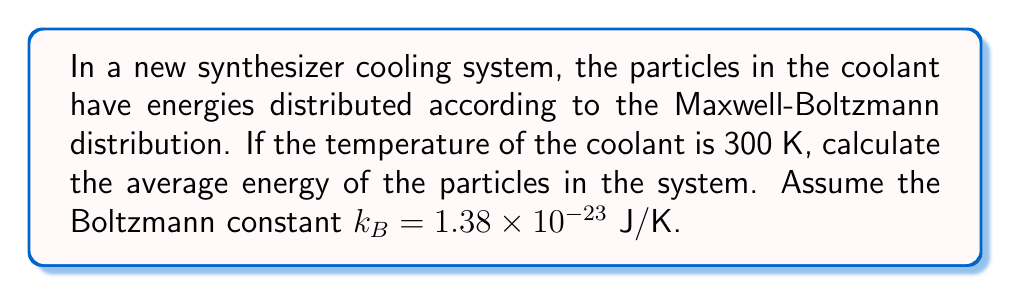Solve this math problem. To solve this problem, we'll follow these steps:

1) In statistical mechanics, the average energy of particles in a thermodynamic system is given by the equipartition theorem. For a system in three dimensions, the average energy per particle is:

   $$\langle E \rangle = \frac{3}{2}k_BT$$

   Where:
   - $\langle E \rangle$ is the average energy per particle
   - $k_B$ is the Boltzmann constant
   - $T$ is the temperature in Kelvin

2) We're given:
   - Temperature $T = 300$ K
   - Boltzmann constant $k_B = 1.38 \times 10^{-23}$ J/K

3) Let's substitute these values into our equation:

   $$\langle E \rangle = \frac{3}{2} \cdot (1.38 \times 10^{-23} \text{ J/K}) \cdot (300 \text{ K})$$

4) Now, let's calculate:

   $$\langle E \rangle = \frac{3}{2} \cdot 4.14 \times 10^{-21} \text{ J}$$
   
   $$\langle E \rangle = 6.21 \times 10^{-21} \text{ J}$$

Therefore, the average energy of particles in the coolant system is $6.21 \times 10^{-21}$ J.
Answer: $6.21 \times 10^{-21}$ J 